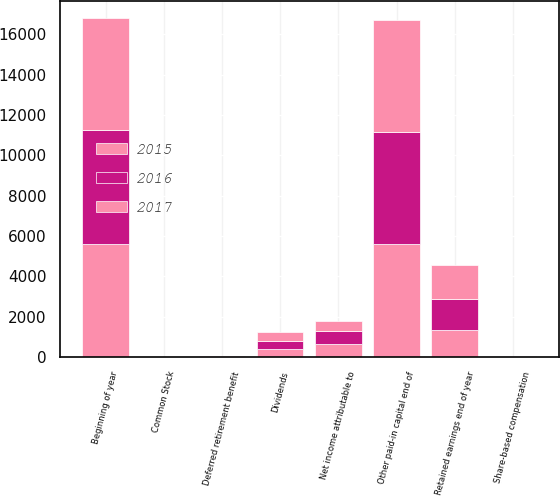<chart> <loc_0><loc_0><loc_500><loc_500><stacked_bar_chart><ecel><fcel>Common Stock<fcel>Beginning of year<fcel>Share-based compensation<fcel>Other paid-in capital end of<fcel>Net income attributable to<fcel>Dividends<fcel>Retained earnings end of year<fcel>Deferred retirement benefit<nl><fcel>2017<fcel>2<fcel>5556<fcel>16<fcel>5540<fcel>523<fcel>431<fcel>1660<fcel>23<nl><fcel>2016<fcel>2<fcel>5616<fcel>60<fcel>5556<fcel>653<fcel>416<fcel>1568<fcel>3<nl><fcel>2015<fcel>2<fcel>5617<fcel>1<fcel>5616<fcel>630<fcel>402<fcel>1331<fcel>9<nl></chart> 